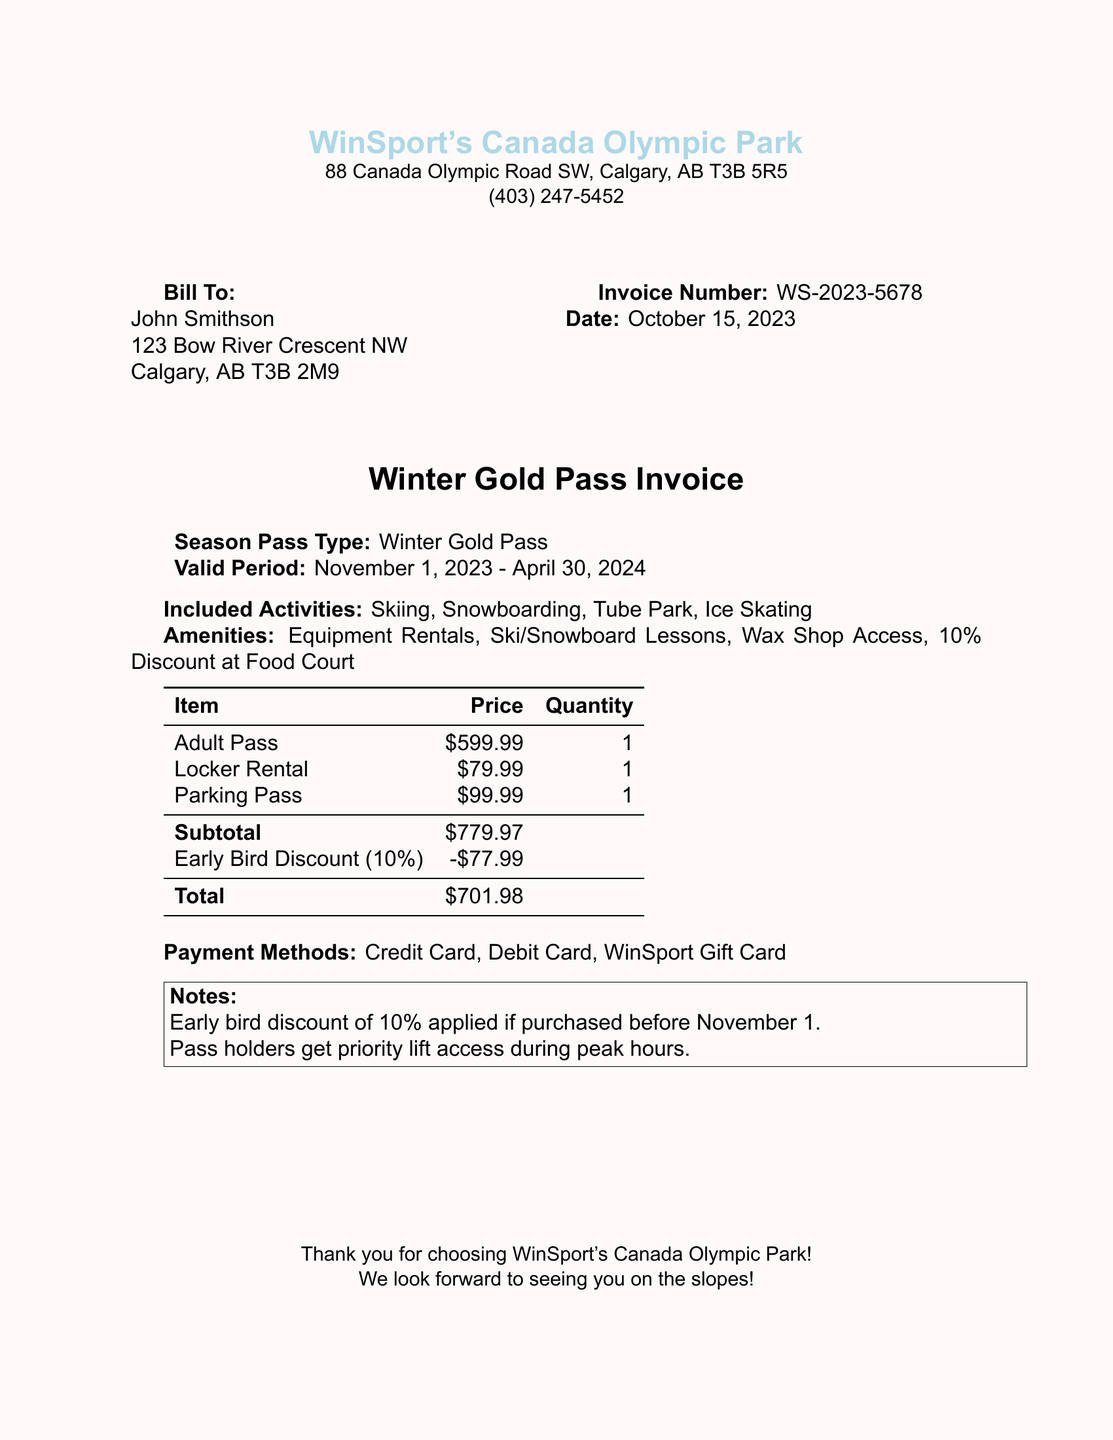What is the invoice number? The invoice number helps identify the specific transaction and is listed in the document as WS-2023-5678.
Answer: WS-2023-5678 What is the total amount due? The total amount due is the final calculated amount after any discounts, shown in the document as $701.98.
Answer: $701.98 What is the valid period for the Winter Gold Pass? The valid period for the pass shows when the pass can be used, which is November 1, 2023 - April 30, 2024.
Answer: November 1, 2023 - April 30, 2024 What type of discount was applied? The discount mentioned in the document is a 10% early bird discount applied if purchased before November 1.
Answer: 10% How many activities are listed under included activities? The document mentions that there are four activities included with the season pass.
Answer: 4 What amenities are included with the pass? Amenities provide additional services, which include Equipment Rentals, Ski/Snowboard Lessons, Wax Shop Access, and a Discount at Food Court.
Answer: Equipment Rentals, Ski/Snowboard Lessons, Wax Shop Access, 10% Discount at Food Court Who is the bill addressed to? The recipient of the bill is important for identifying who is responsible for payment, which is recorded as John Smithson.
Answer: John Smithson What is the parking pass price? The price for the parking pass is specified in the document, depicting the cost associated with parking at the facility.
Answer: $99.99 What are the payment methods accepted? Payment methods are essential for the transaction process and are listed as Credit Card, Debit Card, WinSport Gift Card.
Answer: Credit Card, Debit Card, WinSport Gift Card 